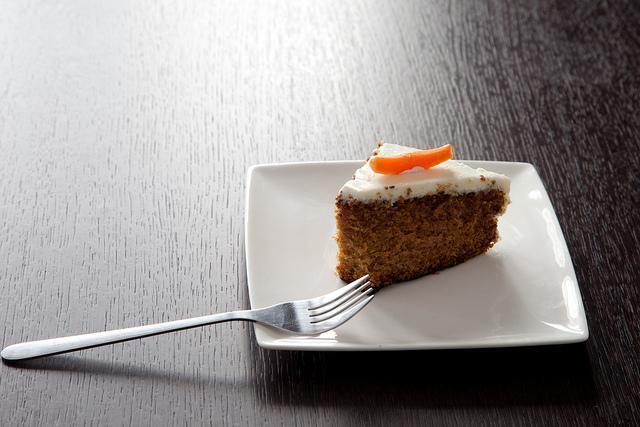What kind of cake has been served?
Make your selection from the four choices given to correctly answer the question.
Options: Cinnamon, red velvet, chocolate, carrot. Carrot. 